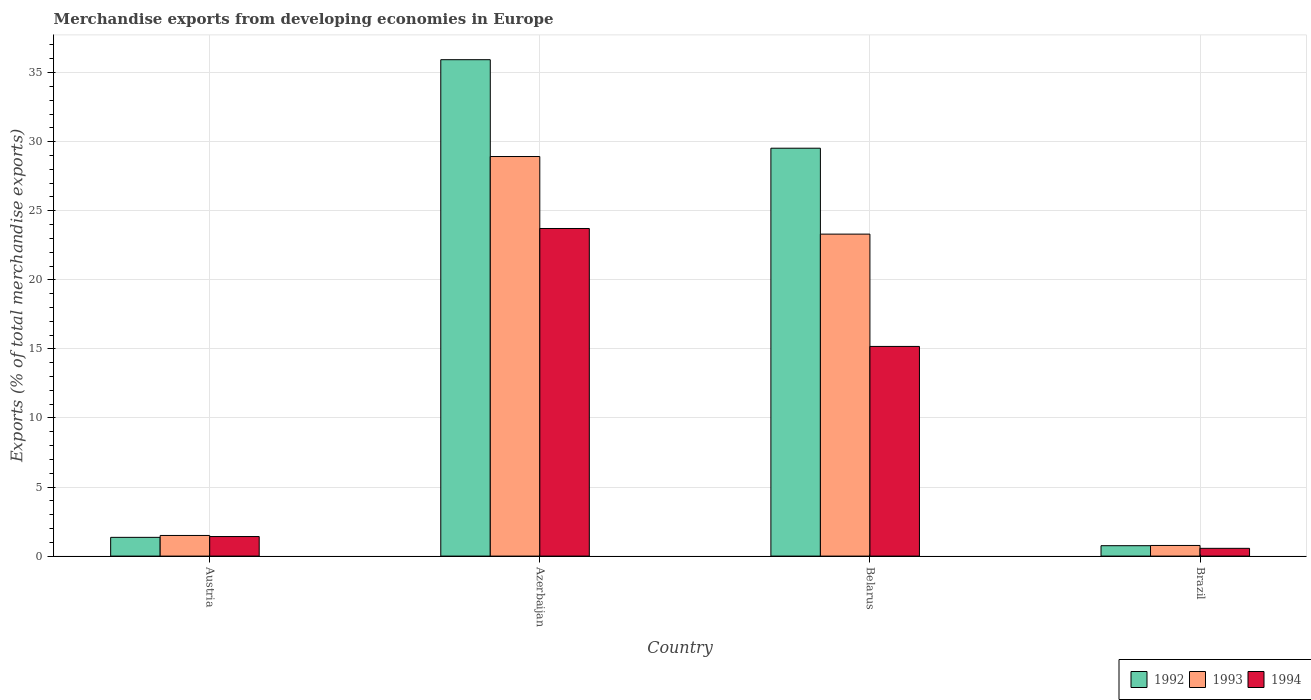How many different coloured bars are there?
Ensure brevity in your answer.  3. Are the number of bars per tick equal to the number of legend labels?
Offer a terse response. Yes. Are the number of bars on each tick of the X-axis equal?
Give a very brief answer. Yes. How many bars are there on the 2nd tick from the left?
Provide a succinct answer. 3. What is the label of the 2nd group of bars from the left?
Your response must be concise. Azerbaijan. What is the percentage of total merchandise exports in 1993 in Belarus?
Make the answer very short. 23.31. Across all countries, what is the maximum percentage of total merchandise exports in 1994?
Offer a terse response. 23.72. Across all countries, what is the minimum percentage of total merchandise exports in 1994?
Keep it short and to the point. 0.56. In which country was the percentage of total merchandise exports in 1994 maximum?
Provide a succinct answer. Azerbaijan. What is the total percentage of total merchandise exports in 1992 in the graph?
Offer a very short reply. 67.57. What is the difference between the percentage of total merchandise exports in 1994 in Belarus and that in Brazil?
Your answer should be compact. 14.62. What is the difference between the percentage of total merchandise exports in 1992 in Austria and the percentage of total merchandise exports in 1993 in Azerbaijan?
Your answer should be compact. -27.57. What is the average percentage of total merchandise exports in 1993 per country?
Provide a succinct answer. 13.62. What is the difference between the percentage of total merchandise exports of/in 1994 and percentage of total merchandise exports of/in 1993 in Azerbaijan?
Your answer should be very brief. -5.21. In how many countries, is the percentage of total merchandise exports in 1992 greater than 15 %?
Provide a short and direct response. 2. What is the ratio of the percentage of total merchandise exports in 1993 in Azerbaijan to that in Brazil?
Provide a short and direct response. 37.55. Is the difference between the percentage of total merchandise exports in 1994 in Austria and Brazil greater than the difference between the percentage of total merchandise exports in 1993 in Austria and Brazil?
Your answer should be very brief. Yes. What is the difference between the highest and the second highest percentage of total merchandise exports in 1994?
Your answer should be very brief. -13.76. What is the difference between the highest and the lowest percentage of total merchandise exports in 1993?
Offer a terse response. 28.16. Is the sum of the percentage of total merchandise exports in 1992 in Austria and Azerbaijan greater than the maximum percentage of total merchandise exports in 1994 across all countries?
Ensure brevity in your answer.  Yes. How many bars are there?
Provide a short and direct response. 12. Are all the bars in the graph horizontal?
Ensure brevity in your answer.  No. How many countries are there in the graph?
Offer a terse response. 4. What is the difference between two consecutive major ticks on the Y-axis?
Provide a succinct answer. 5. Does the graph contain any zero values?
Offer a terse response. No. How many legend labels are there?
Your response must be concise. 3. What is the title of the graph?
Ensure brevity in your answer.  Merchandise exports from developing economies in Europe. Does "1988" appear as one of the legend labels in the graph?
Make the answer very short. No. What is the label or title of the Y-axis?
Provide a succinct answer. Exports (% of total merchandise exports). What is the Exports (% of total merchandise exports) of 1992 in Austria?
Offer a very short reply. 1.36. What is the Exports (% of total merchandise exports) of 1993 in Austria?
Offer a very short reply. 1.49. What is the Exports (% of total merchandise exports) in 1994 in Austria?
Offer a terse response. 1.42. What is the Exports (% of total merchandise exports) of 1992 in Azerbaijan?
Provide a succinct answer. 35.94. What is the Exports (% of total merchandise exports) in 1993 in Azerbaijan?
Ensure brevity in your answer.  28.93. What is the Exports (% of total merchandise exports) of 1994 in Azerbaijan?
Your answer should be compact. 23.72. What is the Exports (% of total merchandise exports) of 1992 in Belarus?
Your response must be concise. 29.53. What is the Exports (% of total merchandise exports) in 1993 in Belarus?
Ensure brevity in your answer.  23.31. What is the Exports (% of total merchandise exports) of 1994 in Belarus?
Your answer should be very brief. 15.18. What is the Exports (% of total merchandise exports) of 1992 in Brazil?
Your response must be concise. 0.75. What is the Exports (% of total merchandise exports) of 1993 in Brazil?
Offer a terse response. 0.77. What is the Exports (% of total merchandise exports) of 1994 in Brazil?
Keep it short and to the point. 0.56. Across all countries, what is the maximum Exports (% of total merchandise exports) of 1992?
Give a very brief answer. 35.94. Across all countries, what is the maximum Exports (% of total merchandise exports) in 1993?
Offer a very short reply. 28.93. Across all countries, what is the maximum Exports (% of total merchandise exports) of 1994?
Give a very brief answer. 23.72. Across all countries, what is the minimum Exports (% of total merchandise exports) in 1992?
Give a very brief answer. 0.75. Across all countries, what is the minimum Exports (% of total merchandise exports) in 1993?
Give a very brief answer. 0.77. Across all countries, what is the minimum Exports (% of total merchandise exports) of 1994?
Give a very brief answer. 0.56. What is the total Exports (% of total merchandise exports) of 1992 in the graph?
Your response must be concise. 67.57. What is the total Exports (% of total merchandise exports) in 1993 in the graph?
Your response must be concise. 54.5. What is the total Exports (% of total merchandise exports) of 1994 in the graph?
Your response must be concise. 40.87. What is the difference between the Exports (% of total merchandise exports) in 1992 in Austria and that in Azerbaijan?
Provide a short and direct response. -34.58. What is the difference between the Exports (% of total merchandise exports) in 1993 in Austria and that in Azerbaijan?
Your answer should be compact. -27.43. What is the difference between the Exports (% of total merchandise exports) of 1994 in Austria and that in Azerbaijan?
Offer a terse response. -22.3. What is the difference between the Exports (% of total merchandise exports) of 1992 in Austria and that in Belarus?
Keep it short and to the point. -28.17. What is the difference between the Exports (% of total merchandise exports) of 1993 in Austria and that in Belarus?
Provide a short and direct response. -21.81. What is the difference between the Exports (% of total merchandise exports) of 1994 in Austria and that in Belarus?
Your answer should be compact. -13.76. What is the difference between the Exports (% of total merchandise exports) in 1992 in Austria and that in Brazil?
Offer a very short reply. 0.6. What is the difference between the Exports (% of total merchandise exports) in 1993 in Austria and that in Brazil?
Keep it short and to the point. 0.72. What is the difference between the Exports (% of total merchandise exports) of 1994 in Austria and that in Brazil?
Offer a terse response. 0.85. What is the difference between the Exports (% of total merchandise exports) in 1992 in Azerbaijan and that in Belarus?
Give a very brief answer. 6.41. What is the difference between the Exports (% of total merchandise exports) in 1993 in Azerbaijan and that in Belarus?
Your answer should be very brief. 5.62. What is the difference between the Exports (% of total merchandise exports) in 1994 in Azerbaijan and that in Belarus?
Give a very brief answer. 8.54. What is the difference between the Exports (% of total merchandise exports) in 1992 in Azerbaijan and that in Brazil?
Offer a very short reply. 35.18. What is the difference between the Exports (% of total merchandise exports) in 1993 in Azerbaijan and that in Brazil?
Your response must be concise. 28.16. What is the difference between the Exports (% of total merchandise exports) in 1994 in Azerbaijan and that in Brazil?
Offer a very short reply. 23.15. What is the difference between the Exports (% of total merchandise exports) of 1992 in Belarus and that in Brazil?
Ensure brevity in your answer.  28.77. What is the difference between the Exports (% of total merchandise exports) of 1993 in Belarus and that in Brazil?
Provide a short and direct response. 22.54. What is the difference between the Exports (% of total merchandise exports) of 1994 in Belarus and that in Brazil?
Offer a terse response. 14.62. What is the difference between the Exports (% of total merchandise exports) in 1992 in Austria and the Exports (% of total merchandise exports) in 1993 in Azerbaijan?
Provide a short and direct response. -27.57. What is the difference between the Exports (% of total merchandise exports) in 1992 in Austria and the Exports (% of total merchandise exports) in 1994 in Azerbaijan?
Ensure brevity in your answer.  -22.36. What is the difference between the Exports (% of total merchandise exports) of 1993 in Austria and the Exports (% of total merchandise exports) of 1994 in Azerbaijan?
Your response must be concise. -22.22. What is the difference between the Exports (% of total merchandise exports) of 1992 in Austria and the Exports (% of total merchandise exports) of 1993 in Belarus?
Give a very brief answer. -21.95. What is the difference between the Exports (% of total merchandise exports) in 1992 in Austria and the Exports (% of total merchandise exports) in 1994 in Belarus?
Keep it short and to the point. -13.82. What is the difference between the Exports (% of total merchandise exports) of 1993 in Austria and the Exports (% of total merchandise exports) of 1994 in Belarus?
Provide a short and direct response. -13.68. What is the difference between the Exports (% of total merchandise exports) of 1992 in Austria and the Exports (% of total merchandise exports) of 1993 in Brazil?
Ensure brevity in your answer.  0.59. What is the difference between the Exports (% of total merchandise exports) of 1992 in Austria and the Exports (% of total merchandise exports) of 1994 in Brazil?
Ensure brevity in your answer.  0.8. What is the difference between the Exports (% of total merchandise exports) of 1993 in Austria and the Exports (% of total merchandise exports) of 1994 in Brazil?
Offer a very short reply. 0.93. What is the difference between the Exports (% of total merchandise exports) in 1992 in Azerbaijan and the Exports (% of total merchandise exports) in 1993 in Belarus?
Offer a terse response. 12.63. What is the difference between the Exports (% of total merchandise exports) of 1992 in Azerbaijan and the Exports (% of total merchandise exports) of 1994 in Belarus?
Offer a very short reply. 20.76. What is the difference between the Exports (% of total merchandise exports) of 1993 in Azerbaijan and the Exports (% of total merchandise exports) of 1994 in Belarus?
Offer a very short reply. 13.75. What is the difference between the Exports (% of total merchandise exports) of 1992 in Azerbaijan and the Exports (% of total merchandise exports) of 1993 in Brazil?
Provide a succinct answer. 35.17. What is the difference between the Exports (% of total merchandise exports) in 1992 in Azerbaijan and the Exports (% of total merchandise exports) in 1994 in Brazil?
Make the answer very short. 35.37. What is the difference between the Exports (% of total merchandise exports) in 1993 in Azerbaijan and the Exports (% of total merchandise exports) in 1994 in Brazil?
Your answer should be compact. 28.36. What is the difference between the Exports (% of total merchandise exports) of 1992 in Belarus and the Exports (% of total merchandise exports) of 1993 in Brazil?
Your answer should be compact. 28.76. What is the difference between the Exports (% of total merchandise exports) in 1992 in Belarus and the Exports (% of total merchandise exports) in 1994 in Brazil?
Your response must be concise. 28.97. What is the difference between the Exports (% of total merchandise exports) of 1993 in Belarus and the Exports (% of total merchandise exports) of 1994 in Brazil?
Provide a short and direct response. 22.75. What is the average Exports (% of total merchandise exports) in 1992 per country?
Provide a succinct answer. 16.89. What is the average Exports (% of total merchandise exports) of 1993 per country?
Provide a succinct answer. 13.62. What is the average Exports (% of total merchandise exports) in 1994 per country?
Make the answer very short. 10.22. What is the difference between the Exports (% of total merchandise exports) of 1992 and Exports (% of total merchandise exports) of 1993 in Austria?
Offer a terse response. -0.14. What is the difference between the Exports (% of total merchandise exports) in 1992 and Exports (% of total merchandise exports) in 1994 in Austria?
Your response must be concise. -0.06. What is the difference between the Exports (% of total merchandise exports) in 1993 and Exports (% of total merchandise exports) in 1994 in Austria?
Offer a terse response. 0.08. What is the difference between the Exports (% of total merchandise exports) of 1992 and Exports (% of total merchandise exports) of 1993 in Azerbaijan?
Give a very brief answer. 7.01. What is the difference between the Exports (% of total merchandise exports) in 1992 and Exports (% of total merchandise exports) in 1994 in Azerbaijan?
Provide a succinct answer. 12.22. What is the difference between the Exports (% of total merchandise exports) of 1993 and Exports (% of total merchandise exports) of 1994 in Azerbaijan?
Provide a succinct answer. 5.21. What is the difference between the Exports (% of total merchandise exports) in 1992 and Exports (% of total merchandise exports) in 1993 in Belarus?
Keep it short and to the point. 6.22. What is the difference between the Exports (% of total merchandise exports) of 1992 and Exports (% of total merchandise exports) of 1994 in Belarus?
Provide a short and direct response. 14.35. What is the difference between the Exports (% of total merchandise exports) in 1993 and Exports (% of total merchandise exports) in 1994 in Belarus?
Offer a very short reply. 8.13. What is the difference between the Exports (% of total merchandise exports) in 1992 and Exports (% of total merchandise exports) in 1993 in Brazil?
Give a very brief answer. -0.02. What is the difference between the Exports (% of total merchandise exports) of 1992 and Exports (% of total merchandise exports) of 1994 in Brazil?
Provide a succinct answer. 0.19. What is the difference between the Exports (% of total merchandise exports) in 1993 and Exports (% of total merchandise exports) in 1994 in Brazil?
Your response must be concise. 0.21. What is the ratio of the Exports (% of total merchandise exports) in 1992 in Austria to that in Azerbaijan?
Keep it short and to the point. 0.04. What is the ratio of the Exports (% of total merchandise exports) of 1993 in Austria to that in Azerbaijan?
Give a very brief answer. 0.05. What is the ratio of the Exports (% of total merchandise exports) in 1994 in Austria to that in Azerbaijan?
Provide a short and direct response. 0.06. What is the ratio of the Exports (% of total merchandise exports) in 1992 in Austria to that in Belarus?
Provide a short and direct response. 0.05. What is the ratio of the Exports (% of total merchandise exports) in 1993 in Austria to that in Belarus?
Provide a short and direct response. 0.06. What is the ratio of the Exports (% of total merchandise exports) of 1994 in Austria to that in Belarus?
Offer a very short reply. 0.09. What is the ratio of the Exports (% of total merchandise exports) of 1992 in Austria to that in Brazil?
Give a very brief answer. 1.8. What is the ratio of the Exports (% of total merchandise exports) in 1993 in Austria to that in Brazil?
Provide a succinct answer. 1.94. What is the ratio of the Exports (% of total merchandise exports) of 1994 in Austria to that in Brazil?
Make the answer very short. 2.52. What is the ratio of the Exports (% of total merchandise exports) of 1992 in Azerbaijan to that in Belarus?
Your response must be concise. 1.22. What is the ratio of the Exports (% of total merchandise exports) in 1993 in Azerbaijan to that in Belarus?
Your response must be concise. 1.24. What is the ratio of the Exports (% of total merchandise exports) of 1994 in Azerbaijan to that in Belarus?
Provide a succinct answer. 1.56. What is the ratio of the Exports (% of total merchandise exports) in 1992 in Azerbaijan to that in Brazil?
Your response must be concise. 47.73. What is the ratio of the Exports (% of total merchandise exports) of 1993 in Azerbaijan to that in Brazil?
Your response must be concise. 37.55. What is the ratio of the Exports (% of total merchandise exports) in 1994 in Azerbaijan to that in Brazil?
Your response must be concise. 42.23. What is the ratio of the Exports (% of total merchandise exports) of 1992 in Belarus to that in Brazil?
Provide a succinct answer. 39.22. What is the ratio of the Exports (% of total merchandise exports) in 1993 in Belarus to that in Brazil?
Provide a short and direct response. 30.26. What is the ratio of the Exports (% of total merchandise exports) in 1994 in Belarus to that in Brazil?
Offer a very short reply. 27.03. What is the difference between the highest and the second highest Exports (% of total merchandise exports) in 1992?
Give a very brief answer. 6.41. What is the difference between the highest and the second highest Exports (% of total merchandise exports) in 1993?
Your response must be concise. 5.62. What is the difference between the highest and the second highest Exports (% of total merchandise exports) of 1994?
Your answer should be compact. 8.54. What is the difference between the highest and the lowest Exports (% of total merchandise exports) in 1992?
Provide a short and direct response. 35.18. What is the difference between the highest and the lowest Exports (% of total merchandise exports) of 1993?
Make the answer very short. 28.16. What is the difference between the highest and the lowest Exports (% of total merchandise exports) of 1994?
Offer a terse response. 23.15. 